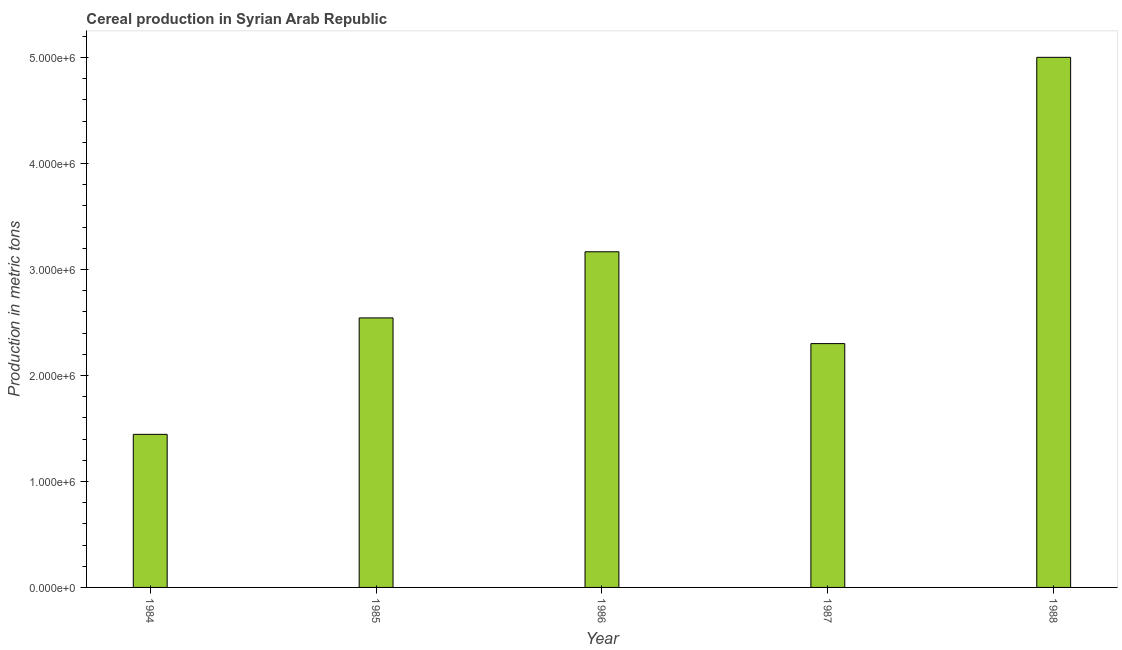What is the title of the graph?
Keep it short and to the point. Cereal production in Syrian Arab Republic. What is the label or title of the Y-axis?
Offer a very short reply. Production in metric tons. What is the cereal production in 1986?
Offer a terse response. 3.17e+06. Across all years, what is the maximum cereal production?
Your answer should be very brief. 5.00e+06. Across all years, what is the minimum cereal production?
Offer a terse response. 1.44e+06. In which year was the cereal production maximum?
Offer a very short reply. 1988. What is the sum of the cereal production?
Your answer should be compact. 1.45e+07. What is the difference between the cereal production in 1984 and 1985?
Give a very brief answer. -1.10e+06. What is the average cereal production per year?
Give a very brief answer. 2.89e+06. What is the median cereal production?
Your answer should be very brief. 2.54e+06. What is the ratio of the cereal production in 1984 to that in 1988?
Offer a terse response. 0.29. Is the difference between the cereal production in 1986 and 1987 greater than the difference between any two years?
Keep it short and to the point. No. What is the difference between the highest and the second highest cereal production?
Provide a succinct answer. 1.83e+06. What is the difference between the highest and the lowest cereal production?
Provide a short and direct response. 3.56e+06. In how many years, is the cereal production greater than the average cereal production taken over all years?
Your answer should be very brief. 2. How many years are there in the graph?
Give a very brief answer. 5. What is the difference between two consecutive major ticks on the Y-axis?
Your answer should be compact. 1.00e+06. Are the values on the major ticks of Y-axis written in scientific E-notation?
Offer a terse response. Yes. What is the Production in metric tons of 1984?
Your answer should be compact. 1.44e+06. What is the Production in metric tons in 1985?
Offer a terse response. 2.54e+06. What is the Production in metric tons in 1986?
Offer a terse response. 3.17e+06. What is the Production in metric tons of 1987?
Your answer should be compact. 2.30e+06. What is the Production in metric tons of 1988?
Offer a very short reply. 5.00e+06. What is the difference between the Production in metric tons in 1984 and 1985?
Ensure brevity in your answer.  -1.10e+06. What is the difference between the Production in metric tons in 1984 and 1986?
Offer a very short reply. -1.72e+06. What is the difference between the Production in metric tons in 1984 and 1987?
Ensure brevity in your answer.  -8.56e+05. What is the difference between the Production in metric tons in 1984 and 1988?
Ensure brevity in your answer.  -3.56e+06. What is the difference between the Production in metric tons in 1985 and 1986?
Your response must be concise. -6.24e+05. What is the difference between the Production in metric tons in 1985 and 1987?
Your response must be concise. 2.42e+05. What is the difference between the Production in metric tons in 1985 and 1988?
Your answer should be compact. -2.46e+06. What is the difference between the Production in metric tons in 1986 and 1987?
Offer a terse response. 8.67e+05. What is the difference between the Production in metric tons in 1986 and 1988?
Ensure brevity in your answer.  -1.83e+06. What is the difference between the Production in metric tons in 1987 and 1988?
Keep it short and to the point. -2.70e+06. What is the ratio of the Production in metric tons in 1984 to that in 1985?
Keep it short and to the point. 0.57. What is the ratio of the Production in metric tons in 1984 to that in 1986?
Your answer should be compact. 0.46. What is the ratio of the Production in metric tons in 1984 to that in 1987?
Ensure brevity in your answer.  0.63. What is the ratio of the Production in metric tons in 1984 to that in 1988?
Your answer should be compact. 0.29. What is the ratio of the Production in metric tons in 1985 to that in 1986?
Give a very brief answer. 0.8. What is the ratio of the Production in metric tons in 1985 to that in 1987?
Offer a terse response. 1.1. What is the ratio of the Production in metric tons in 1985 to that in 1988?
Make the answer very short. 0.51. What is the ratio of the Production in metric tons in 1986 to that in 1987?
Your answer should be very brief. 1.38. What is the ratio of the Production in metric tons in 1986 to that in 1988?
Provide a succinct answer. 0.63. What is the ratio of the Production in metric tons in 1987 to that in 1988?
Ensure brevity in your answer.  0.46. 